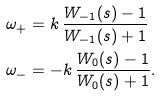Convert formula to latex. <formula><loc_0><loc_0><loc_500><loc_500>\omega _ { + } & = k \, \frac { W _ { - 1 } ( s ) - 1 } { W _ { - 1 } ( s ) + 1 } \\ \omega _ { - } & = - k \, \frac { W _ { 0 } ( s ) - 1 } { W _ { 0 } ( s ) + 1 } .</formula> 